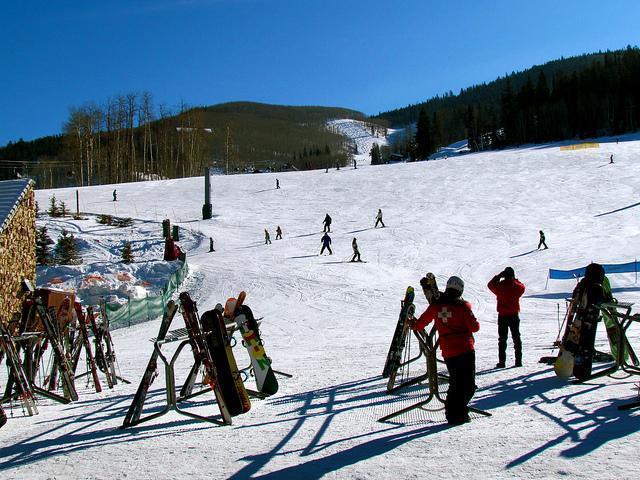The instrument in the picture is used to play for?
Select the accurate response from the four choices given to answer the question.
Options: Snowboarding, skiing, surfing, skating. Skiing. 